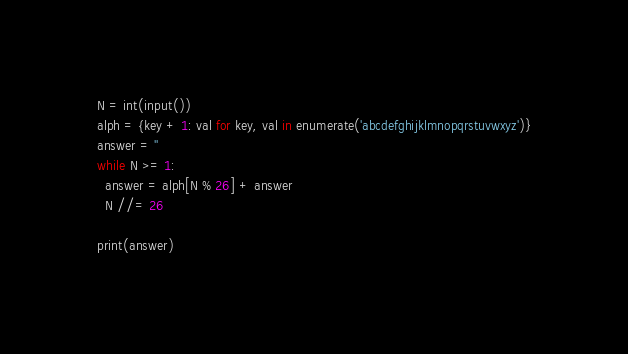<code> <loc_0><loc_0><loc_500><loc_500><_Python_>N = int(input())
alph = {key + 1: val for key, val in enumerate('abcdefghijklmnopqrstuvwxyz')}
answer = ''
while N >= 1:
  answer = alph[N % 26] + answer
  N //= 26

print(answer)</code> 